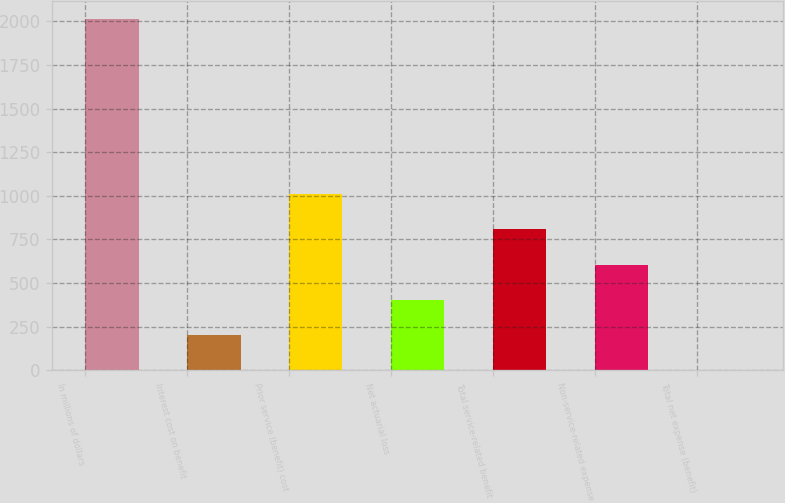Convert chart. <chart><loc_0><loc_0><loc_500><loc_500><bar_chart><fcel>In millions of dollars<fcel>Interest cost on benefit<fcel>Prior service (benefit) cost<fcel>Net actuarial loss<fcel>Total service-related benefit<fcel>Non-service-related expense<fcel>Total net expense (benefit)<nl><fcel>2016<fcel>203.4<fcel>1009<fcel>404.8<fcel>807.6<fcel>606.2<fcel>2<nl></chart> 